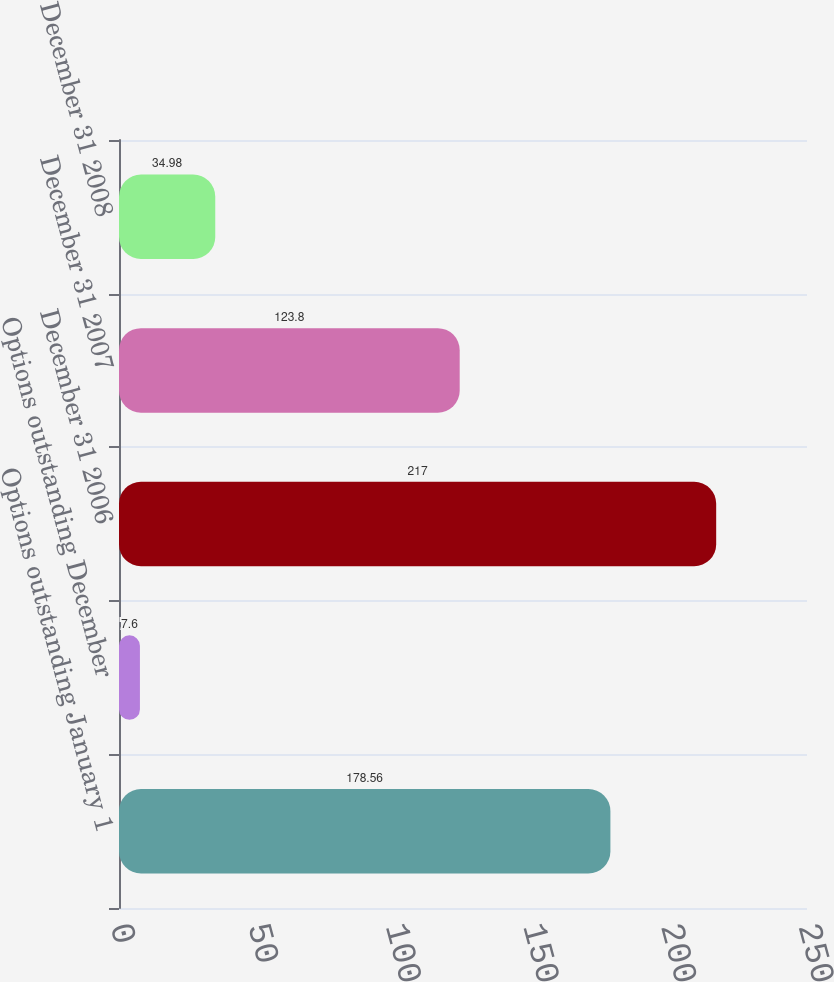Convert chart. <chart><loc_0><loc_0><loc_500><loc_500><bar_chart><fcel>Options outstanding January 1<fcel>Options outstanding December<fcel>December 31 2006<fcel>December 31 2007<fcel>December 31 2008<nl><fcel>178.56<fcel>7.6<fcel>217<fcel>123.8<fcel>34.98<nl></chart> 